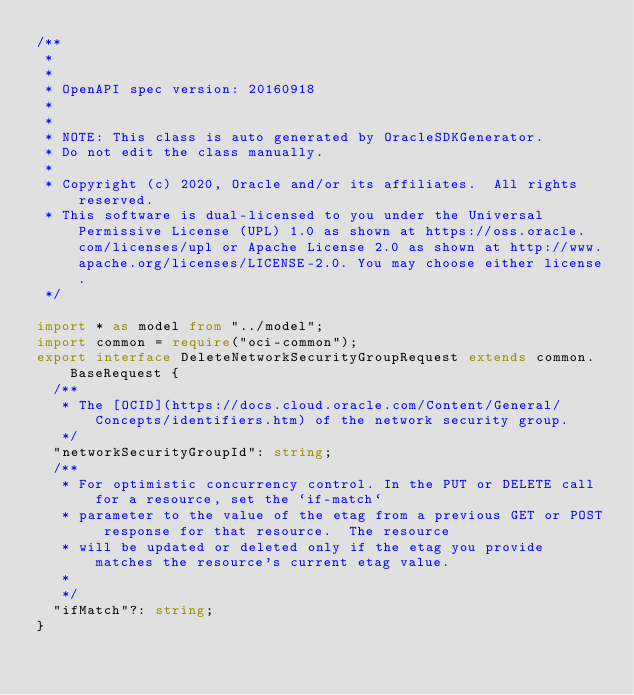Convert code to text. <code><loc_0><loc_0><loc_500><loc_500><_TypeScript_>/**
 *
 *
 * OpenAPI spec version: 20160918
 *
 *
 * NOTE: This class is auto generated by OracleSDKGenerator.
 * Do not edit the class manually.
 *
 * Copyright (c) 2020, Oracle and/or its affiliates.  All rights reserved.
 * This software is dual-licensed to you under the Universal Permissive License (UPL) 1.0 as shown at https://oss.oracle.com/licenses/upl or Apache License 2.0 as shown at http://www.apache.org/licenses/LICENSE-2.0. You may choose either license.
 */

import * as model from "../model";
import common = require("oci-common");
export interface DeleteNetworkSecurityGroupRequest extends common.BaseRequest {
  /**
   * The [OCID](https://docs.cloud.oracle.com/Content/General/Concepts/identifiers.htm) of the network security group.
   */
  "networkSecurityGroupId": string;
  /**
   * For optimistic concurrency control. In the PUT or DELETE call for a resource, set the `if-match`
   * parameter to the value of the etag from a previous GET or POST response for that resource.  The resource
   * will be updated or deleted only if the etag you provide matches the resource's current etag value.
   *
   */
  "ifMatch"?: string;
}
</code> 